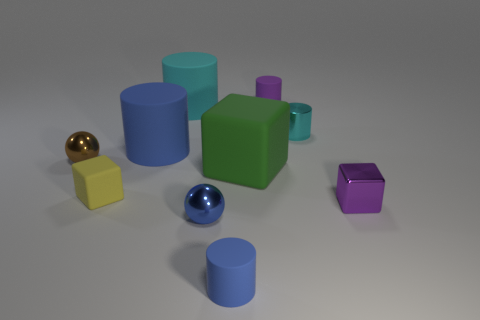Can you tell me more about the golden sphere? Does it serve a purpose in this picture? The golden sphere in the image appears to be a simple reflective object, possibly made of a material like polished metal or a gold-like finish. In the context of this image, it serves as an aesthetic piece that contrasts with the matte finish of the other objects and may be used to demonstrate how light and reflections vary on different surfaces. 